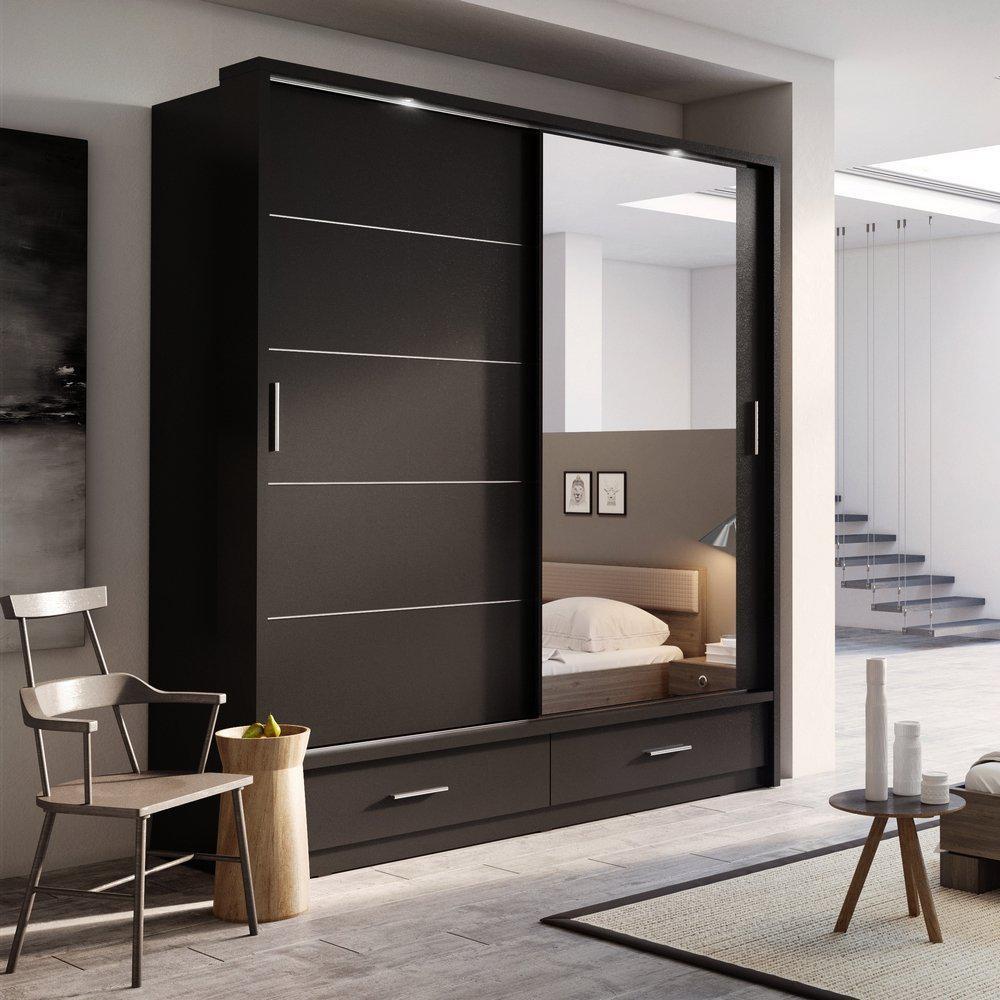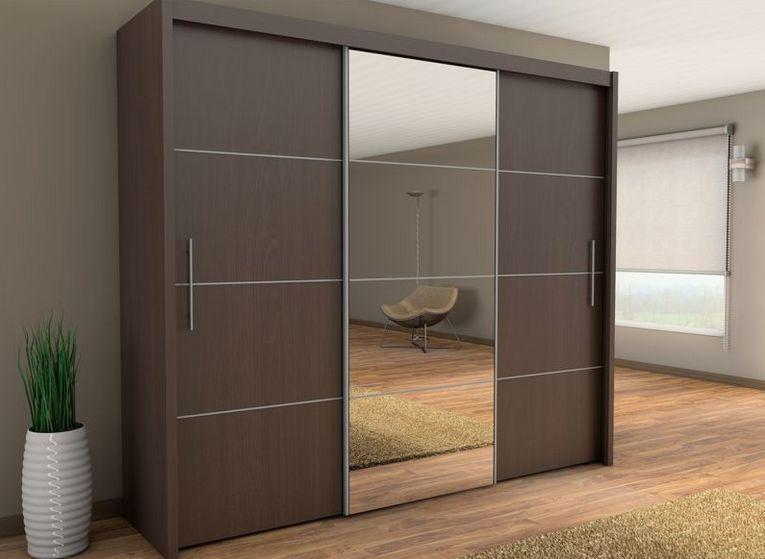The first image is the image on the left, the second image is the image on the right. For the images displayed, is the sentence "A plant is near a sliding cabinet in one of the images." factually correct? Answer yes or no. Yes. The first image is the image on the left, the second image is the image on the right. For the images displayed, is the sentence "An image shows a closed sliding-door unit with at least one mirrored center panel flanked by brown wood panels on the sides." factually correct? Answer yes or no. Yes. 